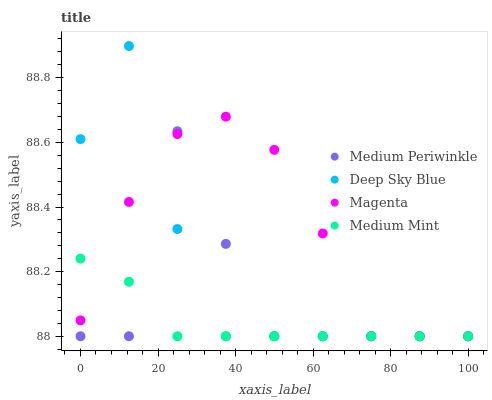Does Medium Mint have the minimum area under the curve?
Answer yes or no. Yes. Does Magenta have the maximum area under the curve?
Answer yes or no. Yes. Does Medium Periwinkle have the minimum area under the curve?
Answer yes or no. No. Does Medium Periwinkle have the maximum area under the curve?
Answer yes or no. No. Is Medium Mint the smoothest?
Answer yes or no. Yes. Is Medium Periwinkle the roughest?
Answer yes or no. Yes. Is Magenta the smoothest?
Answer yes or no. No. Is Magenta the roughest?
Answer yes or no. No. Does Medium Mint have the lowest value?
Answer yes or no. Yes. Does Deep Sky Blue have the highest value?
Answer yes or no. Yes. Does Magenta have the highest value?
Answer yes or no. No. Does Medium Periwinkle intersect Medium Mint?
Answer yes or no. Yes. Is Medium Periwinkle less than Medium Mint?
Answer yes or no. No. Is Medium Periwinkle greater than Medium Mint?
Answer yes or no. No. 